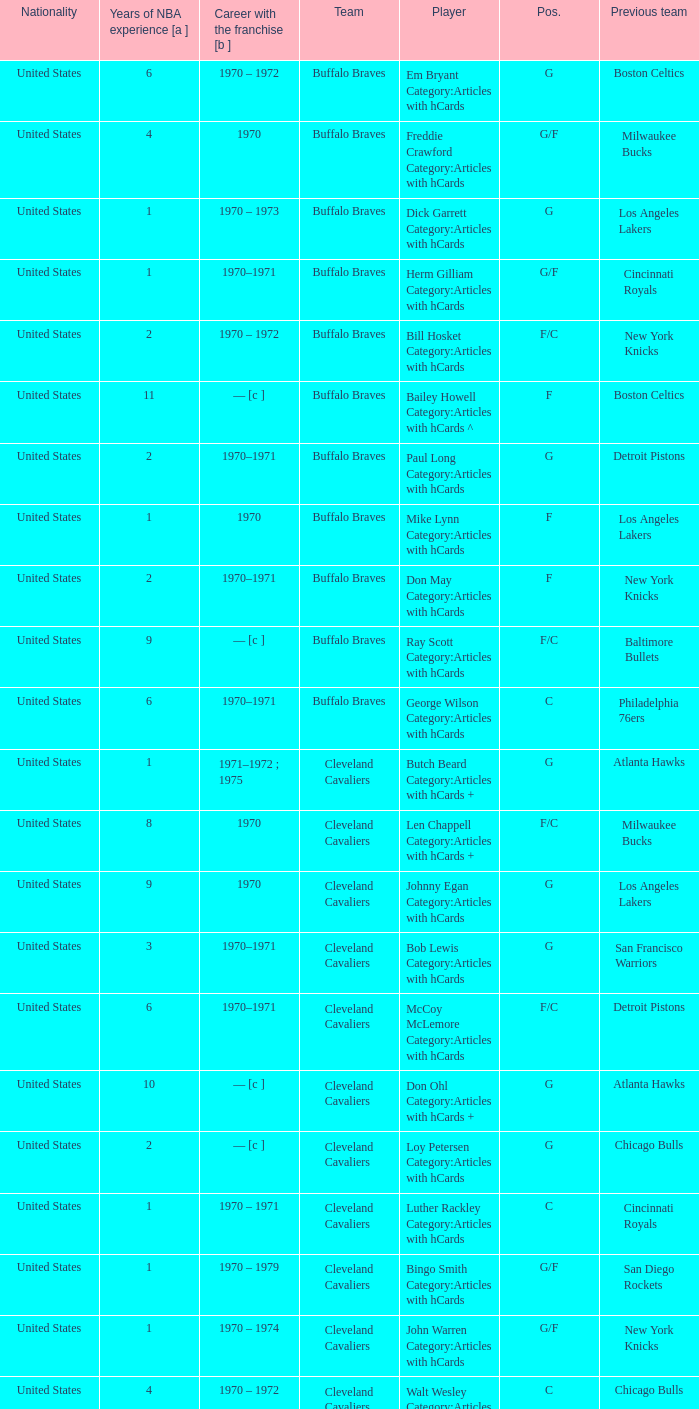How many years of NBA experience does the player who plays position g for the Portland Trail Blazers? 2.0. 